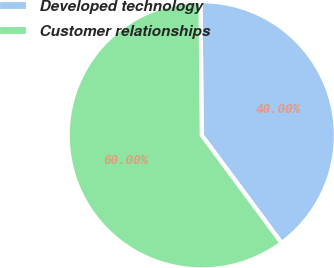<chart> <loc_0><loc_0><loc_500><loc_500><pie_chart><fcel>Developed technology<fcel>Customer relationships<nl><fcel>40.0%<fcel>60.0%<nl></chart> 